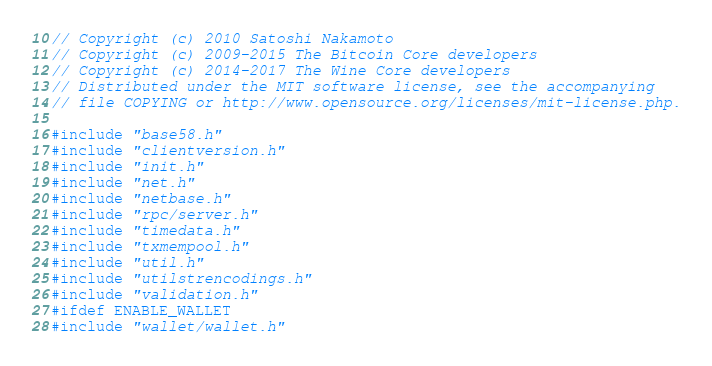Convert code to text. <code><loc_0><loc_0><loc_500><loc_500><_C++_>// Copyright (c) 2010 Satoshi Nakamoto
// Copyright (c) 2009-2015 The Bitcoin Core developers
// Copyright (c) 2014-2017 The Wine Core developers
// Distributed under the MIT software license, see the accompanying
// file COPYING or http://www.opensource.org/licenses/mit-license.php.

#include "base58.h"
#include "clientversion.h"
#include "init.h"
#include "net.h"
#include "netbase.h"
#include "rpc/server.h"
#include "timedata.h"
#include "txmempool.h"
#include "util.h"
#include "utilstrencodings.h"
#include "validation.h"
#ifdef ENABLE_WALLET
#include "wallet/wallet.h"</code> 